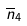Convert formula to latex. <formula><loc_0><loc_0><loc_500><loc_500>\overline { n } _ { 4 }</formula> 